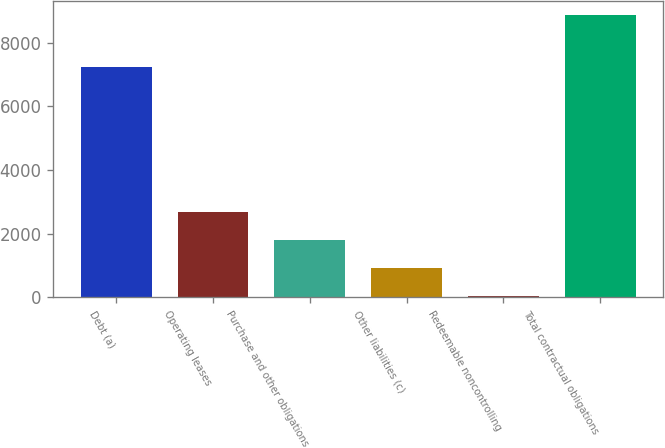<chart> <loc_0><loc_0><loc_500><loc_500><bar_chart><fcel>Debt (a)<fcel>Operating leases<fcel>Purchase and other obligations<fcel>Other liabilities (c)<fcel>Redeemable noncontrolling<fcel>Total contractual obligations<nl><fcel>7241<fcel>2676.4<fcel>1792.6<fcel>908.8<fcel>25<fcel>8863<nl></chart> 